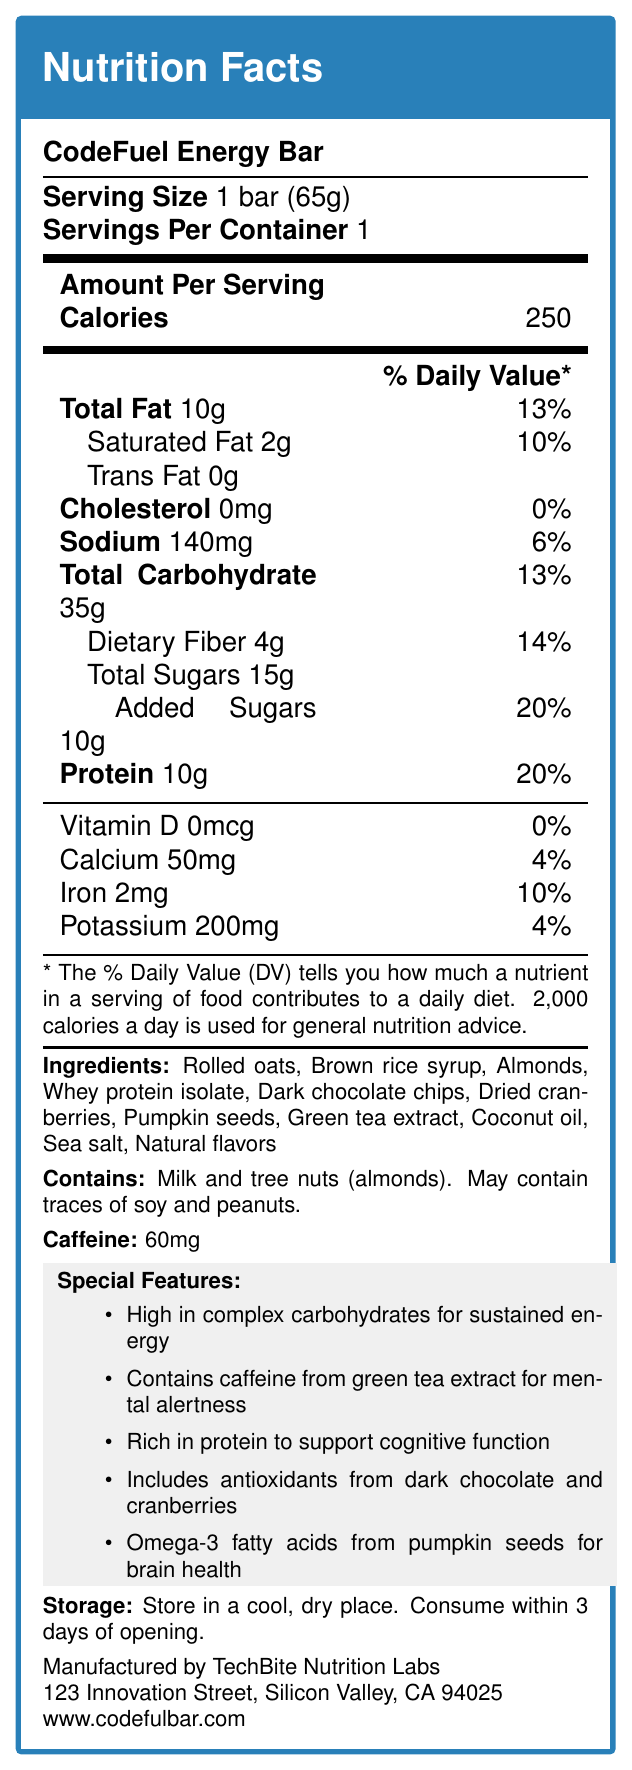what is the serving size of the CodeFuel Energy Bar? The serving size is listed as "1 bar (65g)" at the top of the label under the product name.
Answer: 1 bar (65g) how many calories are in one serving of the CodeFuel Energy Bar? The label indicates that there are 250 calories per serving, found under the "Calories" section.
Answer: 250 calories what is the total amount of fat in the CodeFuel Energy Bar? The Total Fat amount is listed as "10g" in the nutrition facts section of the label.
Answer: 10g what percentage of the daily value for dietary fiber does the CodeFuel Energy Bar provide? The label shows that the dietary fiber content is 4g, which is 14% of the daily value.
Answer: 14% which ingredient provides caffeine in the CodeFuel Energy Bar? According to the ingredients list, "Green tea extract" is the source of caffeine.
Answer: Green tea extract what is the amount of added sugars in the CodeFuel Energy Bar? A. 5g B. 10g C. 15g D. 20g The label lists "Added Sugars" as 10g, which is also 20% of the daily value.
Answer: B. 10g what are the two main allergens in the CodeFuel Energy Bar? A. Soy and peanuts B. Milk and tree nuts C. Wheat and eggs Under the allergens section, it mentions the bar contains "Milk and tree nuts (almonds)."
Answer: B. Milk and tree nuts what is the primary source of protein in the CodeFuel Energy Bar? The ingredient list includes "Whey protein isolate" which is a common source of protein.
Answer: Whey protein isolate does the CodeFuel Energy Bar contain trans fat? The nutrition facts section indicates "Trans Fat 0g."
Answer: No what are the special features highlighted in the document? The bottom section of the document lists special features in a light gray box.
Answer: High in complex carbohydrates for sustained energy, Contains caffeine from green tea extract for mental alertness, Rich in protein to support cognitive function, Includes antioxidants from dark chocolate and cranberries, Omega-3 fatty acids from pumpkin seeds for brain health summarize the main idea of the CodeFuel Energy Bar's nutritional information. The document outlines the nutritional values, ingredients, special features, and storage instructions for the CodeFuel Energy Bar, emphasizing its benefits for prolonged energy and mental acuity.
Answer: The CodeFuel Energy Bar provides 250 calories per serving and contains a balance of macronutrients for sustained energy, mental alertness, and cognitive support. It includes 10g of protein, 35g of carbohydrates, and 10g of total fat. It also features special ingredients for additional health benefits, such as antioxidants and omega-3 fatty acids, and contains 60mg of caffeine. The bar is manufactured by TechBite Nutrition Labs. what is the serving amount of calcium as a percentage of daily value? The label shows that the bar provides 50mg of calcium, which is 4% of the daily value.
Answer: 4% is the CodeFuel Energy Bar suitable for someone avoiding dairy products? The allergen section mentions that the bar contains milk.
Answer: No what is the maximum number of days you should consume the CodeFuel Energy Bar after opening it? The storage instructions specify it should be consumed within 3 days of opening.
Answer: 3 days where is TechBite Nutrition Labs located? The manufacturer's address is listed at the bottom of the document.
Answer: 123 Innovation Street, Silicon Valley, CA 94025 how many milligrams of caffeine does the CodeFuel Energy Bar contain? The label includes a specific section stating that the bar contains 60mg of caffeine.
Answer: 60mg what are Omega-3 fatty acids beneficial for? The special features section mentions that Omega-3 fatty acids from pumpkin seeds are included for brain health.
Answer: Brain health how much iron does the CodeFuel Energy Bar provide as a percentage of daily value? The nutrition facts state that the bar provides 2mg of iron, which equals 10% of the daily value.
Answer: 10% does the CodeFuel Energy Bar include any preservatives? The label does not provide information regarding the presence or absence of preservatives.
Answer: Not enough information 